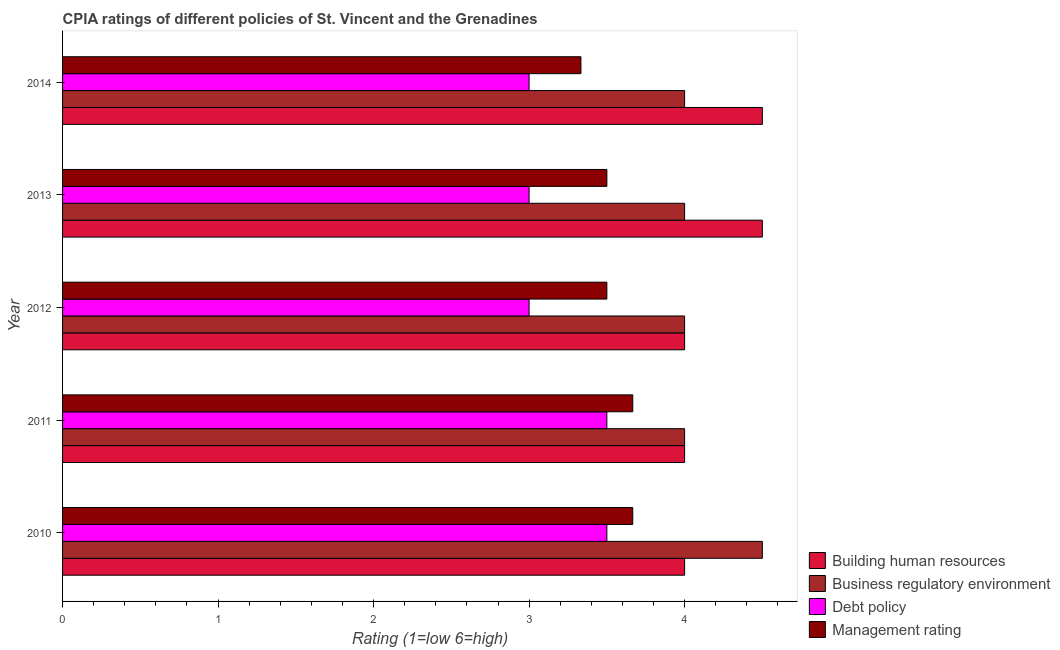How many groups of bars are there?
Make the answer very short. 5. Are the number of bars per tick equal to the number of legend labels?
Your answer should be very brief. Yes. In how many cases, is the number of bars for a given year not equal to the number of legend labels?
Your answer should be compact. 0. What is the cpia rating of management in 2011?
Provide a short and direct response. 3.67. Across all years, what is the maximum cpia rating of building human resources?
Offer a very short reply. 4.5. Across all years, what is the minimum cpia rating of management?
Your response must be concise. 3.33. In which year was the cpia rating of debt policy maximum?
Provide a short and direct response. 2010. In which year was the cpia rating of building human resources minimum?
Your answer should be very brief. 2010. What is the total cpia rating of management in the graph?
Provide a succinct answer. 17.67. In the year 2012, what is the difference between the cpia rating of management and cpia rating of business regulatory environment?
Provide a short and direct response. -0.5. What is the ratio of the cpia rating of building human resources in 2010 to that in 2012?
Give a very brief answer. 1. Is the cpia rating of building human resources in 2011 less than that in 2013?
Keep it short and to the point. Yes. What is the difference between the highest and the second highest cpia rating of management?
Your answer should be compact. 0. What is the difference between the highest and the lowest cpia rating of management?
Offer a terse response. 0.33. In how many years, is the cpia rating of business regulatory environment greater than the average cpia rating of business regulatory environment taken over all years?
Give a very brief answer. 1. Is the sum of the cpia rating of business regulatory environment in 2011 and 2012 greater than the maximum cpia rating of management across all years?
Offer a very short reply. Yes. Is it the case that in every year, the sum of the cpia rating of business regulatory environment and cpia rating of debt policy is greater than the sum of cpia rating of building human resources and cpia rating of management?
Your answer should be very brief. No. What does the 1st bar from the top in 2014 represents?
Offer a very short reply. Management rating. What does the 4th bar from the bottom in 2011 represents?
Provide a succinct answer. Management rating. Does the graph contain any zero values?
Give a very brief answer. No. What is the title of the graph?
Ensure brevity in your answer.  CPIA ratings of different policies of St. Vincent and the Grenadines. What is the Rating (1=low 6=high) of Building human resources in 2010?
Keep it short and to the point. 4. What is the Rating (1=low 6=high) in Debt policy in 2010?
Your response must be concise. 3.5. What is the Rating (1=low 6=high) in Management rating in 2010?
Offer a very short reply. 3.67. What is the Rating (1=low 6=high) in Building human resources in 2011?
Keep it short and to the point. 4. What is the Rating (1=low 6=high) in Management rating in 2011?
Offer a terse response. 3.67. What is the Rating (1=low 6=high) in Building human resources in 2012?
Your answer should be very brief. 4. What is the Rating (1=low 6=high) of Business regulatory environment in 2012?
Your response must be concise. 4. What is the Rating (1=low 6=high) of Debt policy in 2012?
Your answer should be very brief. 3. What is the Rating (1=low 6=high) in Business regulatory environment in 2013?
Your answer should be very brief. 4. What is the Rating (1=low 6=high) in Management rating in 2013?
Offer a very short reply. 3.5. What is the Rating (1=low 6=high) in Building human resources in 2014?
Provide a short and direct response. 4.5. What is the Rating (1=low 6=high) of Management rating in 2014?
Provide a succinct answer. 3.33. Across all years, what is the maximum Rating (1=low 6=high) of Building human resources?
Provide a short and direct response. 4.5. Across all years, what is the maximum Rating (1=low 6=high) in Management rating?
Provide a succinct answer. 3.67. Across all years, what is the minimum Rating (1=low 6=high) of Building human resources?
Your answer should be compact. 4. Across all years, what is the minimum Rating (1=low 6=high) in Business regulatory environment?
Your answer should be compact. 4. Across all years, what is the minimum Rating (1=low 6=high) in Management rating?
Your answer should be compact. 3.33. What is the total Rating (1=low 6=high) in Building human resources in the graph?
Your answer should be very brief. 21. What is the total Rating (1=low 6=high) in Business regulatory environment in the graph?
Offer a very short reply. 20.5. What is the total Rating (1=low 6=high) of Management rating in the graph?
Provide a short and direct response. 17.67. What is the difference between the Rating (1=low 6=high) in Management rating in 2010 and that in 2011?
Your response must be concise. 0. What is the difference between the Rating (1=low 6=high) of Building human resources in 2010 and that in 2012?
Your answer should be very brief. 0. What is the difference between the Rating (1=low 6=high) of Business regulatory environment in 2010 and that in 2013?
Your response must be concise. 0.5. What is the difference between the Rating (1=low 6=high) of Debt policy in 2010 and that in 2013?
Your response must be concise. 0.5. What is the difference between the Rating (1=low 6=high) in Building human resources in 2010 and that in 2014?
Ensure brevity in your answer.  -0.5. What is the difference between the Rating (1=low 6=high) in Building human resources in 2011 and that in 2012?
Give a very brief answer. 0. What is the difference between the Rating (1=low 6=high) of Building human resources in 2011 and that in 2014?
Your answer should be very brief. -0.5. What is the difference between the Rating (1=low 6=high) in Business regulatory environment in 2011 and that in 2014?
Your response must be concise. 0. What is the difference between the Rating (1=low 6=high) in Management rating in 2011 and that in 2014?
Make the answer very short. 0.33. What is the difference between the Rating (1=low 6=high) of Building human resources in 2012 and that in 2013?
Give a very brief answer. -0.5. What is the difference between the Rating (1=low 6=high) in Management rating in 2012 and that in 2013?
Your answer should be very brief. 0. What is the difference between the Rating (1=low 6=high) of Business regulatory environment in 2012 and that in 2014?
Give a very brief answer. 0. What is the difference between the Rating (1=low 6=high) in Debt policy in 2012 and that in 2014?
Offer a very short reply. 0. What is the difference between the Rating (1=low 6=high) of Management rating in 2012 and that in 2014?
Your answer should be compact. 0.17. What is the difference between the Rating (1=low 6=high) in Building human resources in 2013 and that in 2014?
Your answer should be very brief. 0. What is the difference between the Rating (1=low 6=high) of Debt policy in 2013 and that in 2014?
Offer a terse response. 0. What is the difference between the Rating (1=low 6=high) in Management rating in 2013 and that in 2014?
Your answer should be very brief. 0.17. What is the difference between the Rating (1=low 6=high) in Building human resources in 2010 and the Rating (1=low 6=high) in Business regulatory environment in 2011?
Keep it short and to the point. 0. What is the difference between the Rating (1=low 6=high) of Business regulatory environment in 2010 and the Rating (1=low 6=high) of Debt policy in 2011?
Ensure brevity in your answer.  1. What is the difference between the Rating (1=low 6=high) in Debt policy in 2010 and the Rating (1=low 6=high) in Management rating in 2011?
Your response must be concise. -0.17. What is the difference between the Rating (1=low 6=high) in Building human resources in 2010 and the Rating (1=low 6=high) in Debt policy in 2012?
Provide a succinct answer. 1. What is the difference between the Rating (1=low 6=high) of Building human resources in 2010 and the Rating (1=low 6=high) of Management rating in 2012?
Your response must be concise. 0.5. What is the difference between the Rating (1=low 6=high) of Business regulatory environment in 2010 and the Rating (1=low 6=high) of Management rating in 2012?
Offer a terse response. 1. What is the difference between the Rating (1=low 6=high) of Debt policy in 2010 and the Rating (1=low 6=high) of Management rating in 2012?
Your answer should be compact. 0. What is the difference between the Rating (1=low 6=high) in Building human resources in 2010 and the Rating (1=low 6=high) in Business regulatory environment in 2013?
Ensure brevity in your answer.  0. What is the difference between the Rating (1=low 6=high) of Building human resources in 2010 and the Rating (1=low 6=high) of Debt policy in 2013?
Provide a short and direct response. 1. What is the difference between the Rating (1=low 6=high) in Building human resources in 2010 and the Rating (1=low 6=high) in Management rating in 2013?
Provide a succinct answer. 0.5. What is the difference between the Rating (1=low 6=high) of Business regulatory environment in 2010 and the Rating (1=low 6=high) of Management rating in 2013?
Offer a terse response. 1. What is the difference between the Rating (1=low 6=high) in Building human resources in 2010 and the Rating (1=low 6=high) in Business regulatory environment in 2014?
Your answer should be very brief. 0. What is the difference between the Rating (1=low 6=high) in Building human resources in 2010 and the Rating (1=low 6=high) in Debt policy in 2014?
Provide a succinct answer. 1. What is the difference between the Rating (1=low 6=high) of Business regulatory environment in 2010 and the Rating (1=low 6=high) of Debt policy in 2014?
Give a very brief answer. 1.5. What is the difference between the Rating (1=low 6=high) in Business regulatory environment in 2010 and the Rating (1=low 6=high) in Management rating in 2014?
Your response must be concise. 1.17. What is the difference between the Rating (1=low 6=high) of Debt policy in 2010 and the Rating (1=low 6=high) of Management rating in 2014?
Keep it short and to the point. 0.17. What is the difference between the Rating (1=low 6=high) in Building human resources in 2011 and the Rating (1=low 6=high) in Debt policy in 2012?
Your answer should be very brief. 1. What is the difference between the Rating (1=low 6=high) of Building human resources in 2011 and the Rating (1=low 6=high) of Management rating in 2012?
Offer a very short reply. 0.5. What is the difference between the Rating (1=low 6=high) in Business regulatory environment in 2011 and the Rating (1=low 6=high) in Debt policy in 2012?
Provide a short and direct response. 1. What is the difference between the Rating (1=low 6=high) in Building human resources in 2011 and the Rating (1=low 6=high) in Business regulatory environment in 2013?
Offer a very short reply. 0. What is the difference between the Rating (1=low 6=high) in Building human resources in 2011 and the Rating (1=low 6=high) in Management rating in 2013?
Offer a very short reply. 0.5. What is the difference between the Rating (1=low 6=high) of Debt policy in 2011 and the Rating (1=low 6=high) of Management rating in 2013?
Make the answer very short. 0. What is the difference between the Rating (1=low 6=high) in Building human resources in 2011 and the Rating (1=low 6=high) in Business regulatory environment in 2014?
Your response must be concise. 0. What is the difference between the Rating (1=low 6=high) of Business regulatory environment in 2011 and the Rating (1=low 6=high) of Debt policy in 2014?
Offer a very short reply. 1. What is the difference between the Rating (1=low 6=high) in Business regulatory environment in 2011 and the Rating (1=low 6=high) in Management rating in 2014?
Provide a succinct answer. 0.67. What is the difference between the Rating (1=low 6=high) in Business regulatory environment in 2012 and the Rating (1=low 6=high) in Management rating in 2014?
Give a very brief answer. 0.67. What is the difference between the Rating (1=low 6=high) of Business regulatory environment in 2013 and the Rating (1=low 6=high) of Debt policy in 2014?
Your response must be concise. 1. What is the difference between the Rating (1=low 6=high) of Debt policy in 2013 and the Rating (1=low 6=high) of Management rating in 2014?
Give a very brief answer. -0.33. What is the average Rating (1=low 6=high) in Business regulatory environment per year?
Offer a very short reply. 4.1. What is the average Rating (1=low 6=high) in Management rating per year?
Offer a very short reply. 3.53. In the year 2010, what is the difference between the Rating (1=low 6=high) of Building human resources and Rating (1=low 6=high) of Debt policy?
Ensure brevity in your answer.  0.5. In the year 2010, what is the difference between the Rating (1=low 6=high) of Building human resources and Rating (1=low 6=high) of Management rating?
Your answer should be very brief. 0.33. In the year 2010, what is the difference between the Rating (1=low 6=high) of Business regulatory environment and Rating (1=low 6=high) of Management rating?
Your answer should be very brief. 0.83. In the year 2010, what is the difference between the Rating (1=low 6=high) in Debt policy and Rating (1=low 6=high) in Management rating?
Give a very brief answer. -0.17. In the year 2011, what is the difference between the Rating (1=low 6=high) in Building human resources and Rating (1=low 6=high) in Business regulatory environment?
Make the answer very short. 0. In the year 2012, what is the difference between the Rating (1=low 6=high) in Building human resources and Rating (1=low 6=high) in Business regulatory environment?
Offer a very short reply. 0. In the year 2012, what is the difference between the Rating (1=low 6=high) in Building human resources and Rating (1=low 6=high) in Debt policy?
Ensure brevity in your answer.  1. In the year 2012, what is the difference between the Rating (1=low 6=high) of Business regulatory environment and Rating (1=low 6=high) of Management rating?
Keep it short and to the point. 0.5. In the year 2012, what is the difference between the Rating (1=low 6=high) of Debt policy and Rating (1=low 6=high) of Management rating?
Provide a succinct answer. -0.5. In the year 2013, what is the difference between the Rating (1=low 6=high) of Building human resources and Rating (1=low 6=high) of Business regulatory environment?
Provide a short and direct response. 0.5. In the year 2013, what is the difference between the Rating (1=low 6=high) in Building human resources and Rating (1=low 6=high) in Debt policy?
Keep it short and to the point. 1.5. In the year 2013, what is the difference between the Rating (1=low 6=high) of Building human resources and Rating (1=low 6=high) of Management rating?
Keep it short and to the point. 1. In the year 2014, what is the difference between the Rating (1=low 6=high) in Building human resources and Rating (1=low 6=high) in Management rating?
Ensure brevity in your answer.  1.17. In the year 2014, what is the difference between the Rating (1=low 6=high) in Business regulatory environment and Rating (1=low 6=high) in Management rating?
Your response must be concise. 0.67. What is the ratio of the Rating (1=low 6=high) in Building human resources in 2010 to that in 2011?
Offer a very short reply. 1. What is the ratio of the Rating (1=low 6=high) of Business regulatory environment in 2010 to that in 2011?
Offer a terse response. 1.12. What is the ratio of the Rating (1=low 6=high) of Debt policy in 2010 to that in 2011?
Give a very brief answer. 1. What is the ratio of the Rating (1=low 6=high) of Management rating in 2010 to that in 2011?
Keep it short and to the point. 1. What is the ratio of the Rating (1=low 6=high) in Debt policy in 2010 to that in 2012?
Give a very brief answer. 1.17. What is the ratio of the Rating (1=low 6=high) of Management rating in 2010 to that in 2012?
Provide a succinct answer. 1.05. What is the ratio of the Rating (1=low 6=high) of Building human resources in 2010 to that in 2013?
Your response must be concise. 0.89. What is the ratio of the Rating (1=low 6=high) of Business regulatory environment in 2010 to that in 2013?
Make the answer very short. 1.12. What is the ratio of the Rating (1=low 6=high) in Management rating in 2010 to that in 2013?
Make the answer very short. 1.05. What is the ratio of the Rating (1=low 6=high) of Building human resources in 2010 to that in 2014?
Give a very brief answer. 0.89. What is the ratio of the Rating (1=low 6=high) of Debt policy in 2010 to that in 2014?
Keep it short and to the point. 1.17. What is the ratio of the Rating (1=low 6=high) of Business regulatory environment in 2011 to that in 2012?
Make the answer very short. 1. What is the ratio of the Rating (1=low 6=high) in Management rating in 2011 to that in 2012?
Offer a terse response. 1.05. What is the ratio of the Rating (1=low 6=high) of Debt policy in 2011 to that in 2013?
Your answer should be compact. 1.17. What is the ratio of the Rating (1=low 6=high) of Management rating in 2011 to that in 2013?
Your response must be concise. 1.05. What is the ratio of the Rating (1=low 6=high) of Debt policy in 2011 to that in 2014?
Offer a terse response. 1.17. What is the ratio of the Rating (1=low 6=high) in Building human resources in 2012 to that in 2013?
Provide a succinct answer. 0.89. What is the ratio of the Rating (1=low 6=high) of Debt policy in 2012 to that in 2013?
Provide a succinct answer. 1. What is the ratio of the Rating (1=low 6=high) of Building human resources in 2012 to that in 2014?
Ensure brevity in your answer.  0.89. What is the ratio of the Rating (1=low 6=high) of Business regulatory environment in 2012 to that in 2014?
Ensure brevity in your answer.  1. What is the ratio of the Rating (1=low 6=high) in Building human resources in 2013 to that in 2014?
Ensure brevity in your answer.  1. What is the ratio of the Rating (1=low 6=high) in Business regulatory environment in 2013 to that in 2014?
Offer a very short reply. 1. What is the ratio of the Rating (1=low 6=high) in Management rating in 2013 to that in 2014?
Your response must be concise. 1.05. What is the difference between the highest and the second highest Rating (1=low 6=high) in Business regulatory environment?
Offer a very short reply. 0.5. What is the difference between the highest and the lowest Rating (1=low 6=high) in Management rating?
Offer a very short reply. 0.33. 